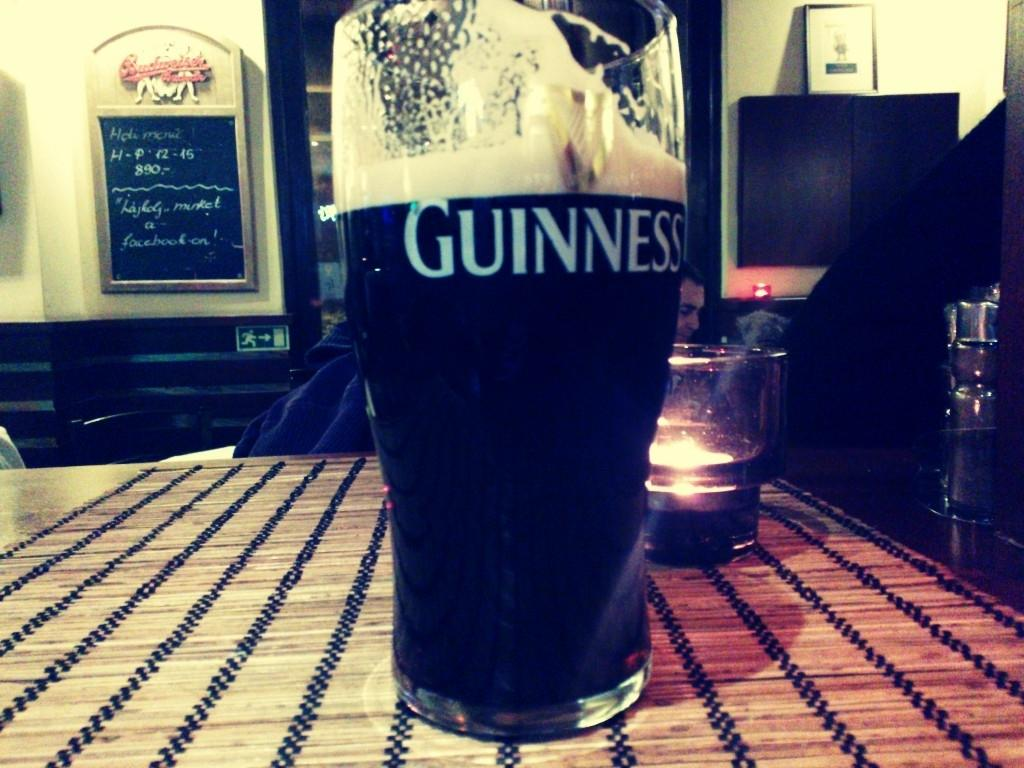<image>
Share a concise interpretation of the image provided. the word Guinness is on a glass of beer 